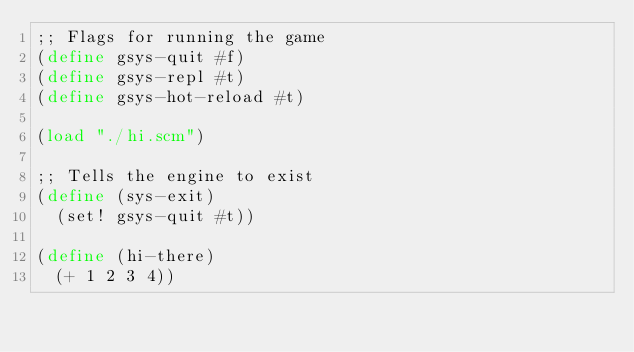Convert code to text. <code><loc_0><loc_0><loc_500><loc_500><_Scheme_>;; Flags for running the game
(define gsys-quit #f)
(define gsys-repl #t)
(define gsys-hot-reload #t)

(load "./hi.scm")

;; Tells the engine to exist
(define (sys-exit)
	(set! gsys-quit #t))

(define (hi-there)
	(+ 1 2 3 4))</code> 